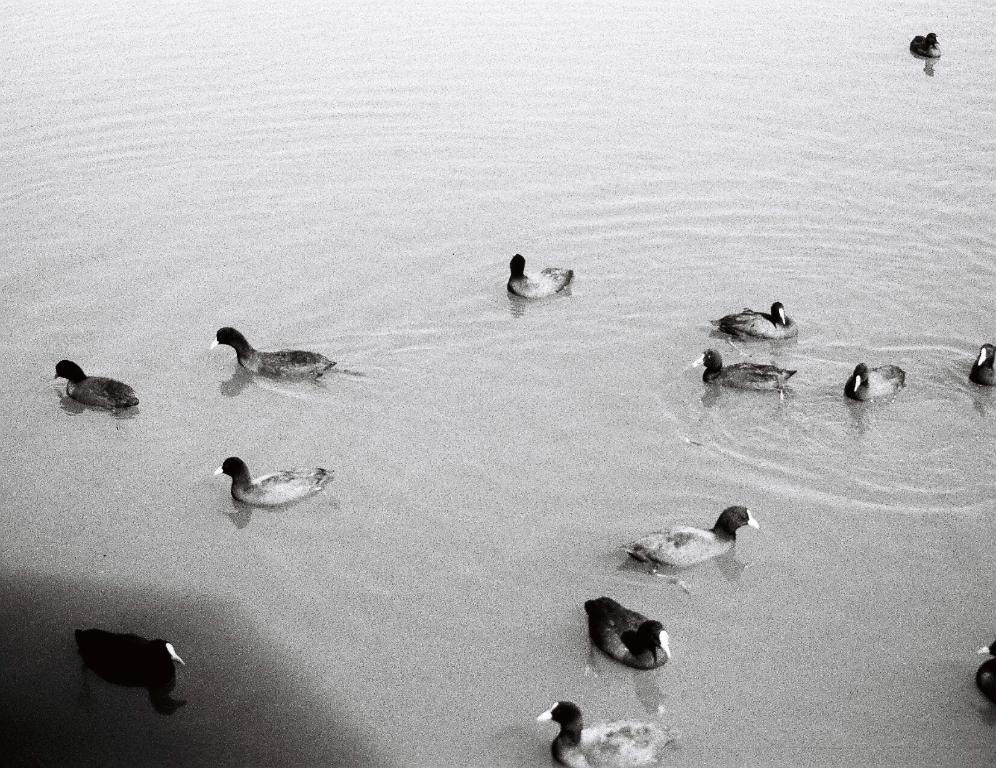What is the color scheme of the image? The image is black and white. What can be seen in the image besides the color scheme? There is water visible in the image. What is present in the water? There are ducks swimming in the water. What type of skirt is the duck wearing in the image? Ducks do not wear skirts, and there are no skirts present in the image. 